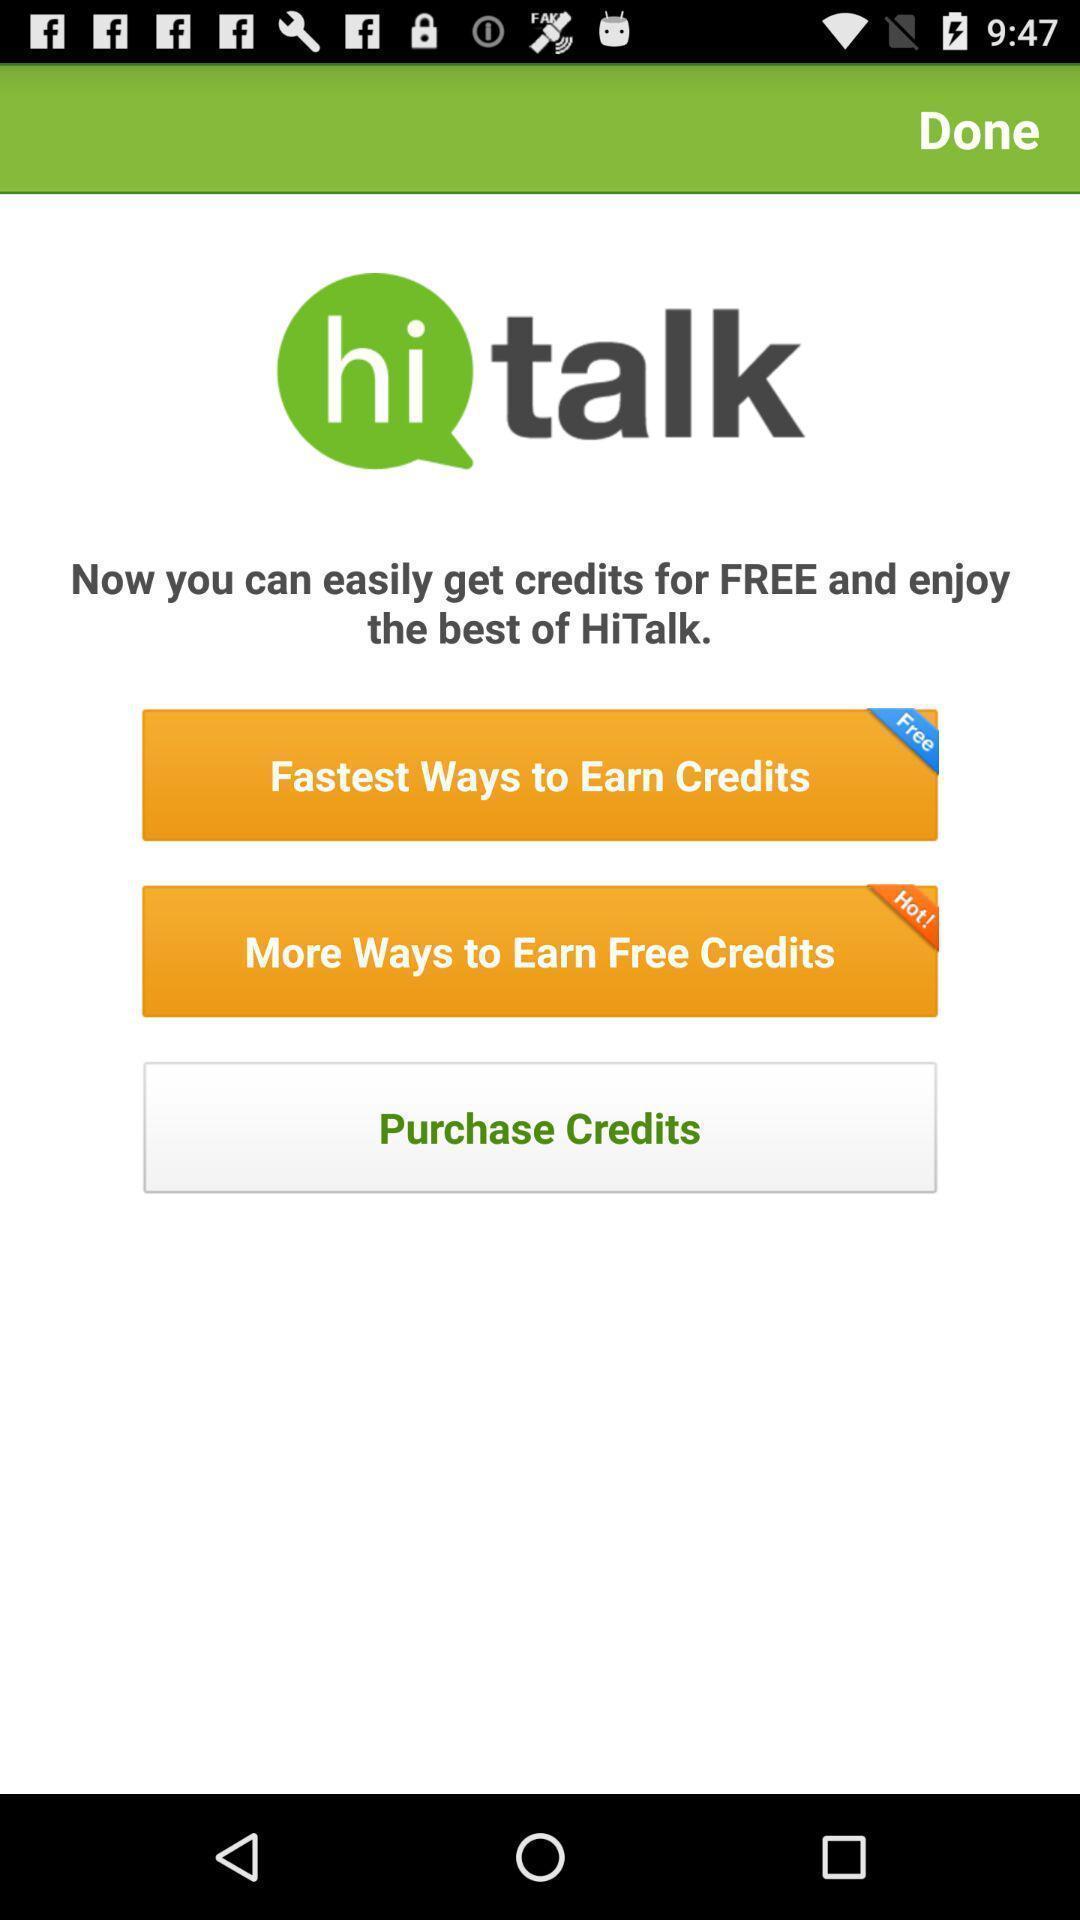What is the overall content of this screenshot? Screen showing the welcome page of an social app. 